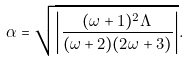<formula> <loc_0><loc_0><loc_500><loc_500>\alpha = \sqrt { \left | \frac { ( \omega + 1 ) ^ { 2 } \Lambda } { ( \omega + 2 ) ( 2 \omega + 3 ) } \right | } .</formula> 